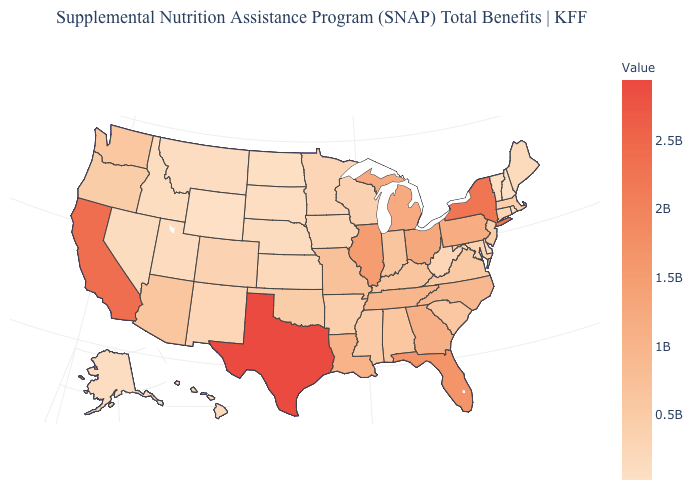Does Wyoming have the lowest value in the USA?
Write a very short answer. Yes. Which states hav the highest value in the West?
Give a very brief answer. California. Which states have the lowest value in the USA?
Answer briefly. Wyoming. Does North Dakota have the lowest value in the MidWest?
Give a very brief answer. Yes. Does New Mexico have a higher value than Kentucky?
Short answer required. No. Does North Dakota have a higher value than Illinois?
Concise answer only. No. 